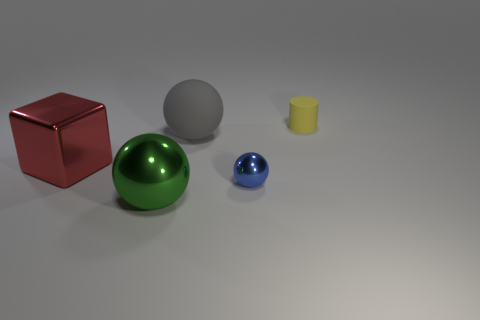There is a metal ball right of the big sphere that is behind the thing to the left of the big metallic sphere; what is its color?
Ensure brevity in your answer.  Blue. Is there any other thing that has the same size as the cube?
Offer a terse response. Yes. There is a matte ball; does it have the same color as the metal object that is on the right side of the large metal sphere?
Provide a succinct answer. No. The matte cylinder has what color?
Offer a terse response. Yellow. There is a shiny thing right of the big ball that is in front of the matte object in front of the matte cylinder; what is its shape?
Your response must be concise. Sphere. Are there more balls that are behind the green metal sphere than rubber objects right of the gray matte ball?
Offer a very short reply. Yes. Are there any yellow rubber cylinders behind the red object?
Offer a very short reply. Yes. What is the material of the sphere that is both in front of the large matte thing and on the left side of the small blue shiny ball?
Make the answer very short. Metal. What is the color of the other big thing that is the same shape as the big rubber object?
Keep it short and to the point. Green. Is there a metal sphere on the right side of the rubber object on the left side of the yellow rubber thing?
Your response must be concise. Yes. 